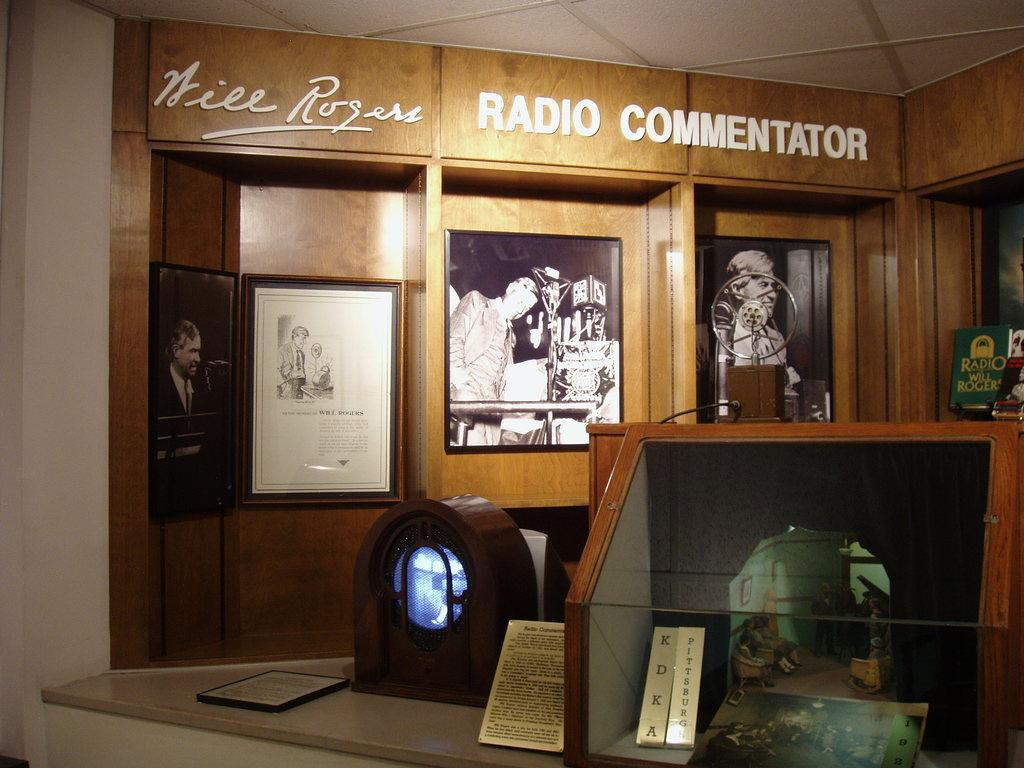Provide a one-sentence caption for the provided image. A radio station of the radio commentator Nill Rogers with old pictures of him on the wall. 